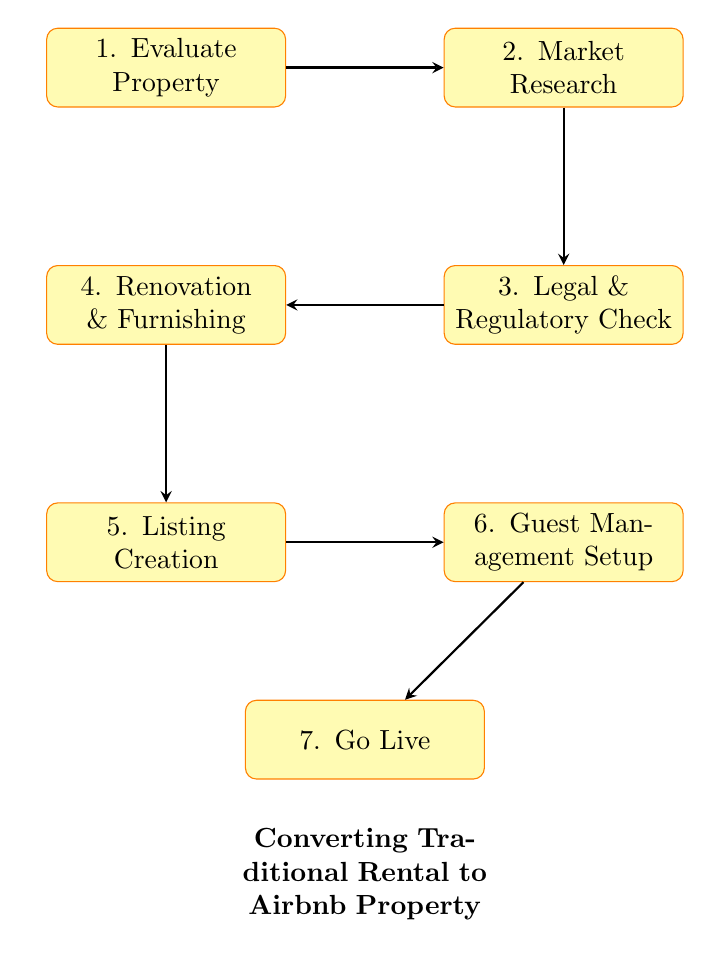What is the first step in the process? The diagram indicates that the first step in the process is "Evaluate Property." This is the starting node and is connected to the next step, "Market Research."
Answer: Evaluate Property How many total steps are there in the process? Counting the nodes, there are 7 steps in the process, which includes each of the nodes listed in the diagram.
Answer: 7 What is the relationship between "Market Research" and "Legal & Regulatory Check"? "Market Research" points to "Legal & Regulatory Check" indicating that after conducting market research, the next step is to ensure legal and regulatory compliance. This is a direct connection as shown by the arrow in the diagram.
Answer: Direct connection What step follows "Guest Management Setup"? The diagram shows that "Guest Management Setup" leads to the final step, "Go Live." Therefore, the step that follows is "Go Live."
Answer: Go Live What does the "Renovation & Furnishing" node depend on? The node "Renovation & Furnishing" depends on the completion of "Legal & Regulatory Check," indicating that any renovations or furnishing should occur after ensuring compliance with regulations.
Answer: Legal & Regulatory Check In which step is the property listed on Airbnb? The "Listing Creation" step is where the property is created as a listing on Airbnb, including high-quality photos and descriptions.
Answer: Listing Creation Which step comes before "Go Live"? The step that precedes "Go Live" is "Guest Management Setup," indicating that managing guest communications and bookings should be established before going live with the listing.
Answer: Guest Management Setup What is the last requirement before publishing the listing? The last requirement before publishing the listing is the setup of "Guest Management," which includes ensuring proper systems for managing guests.
Answer: Guest Management Setup 